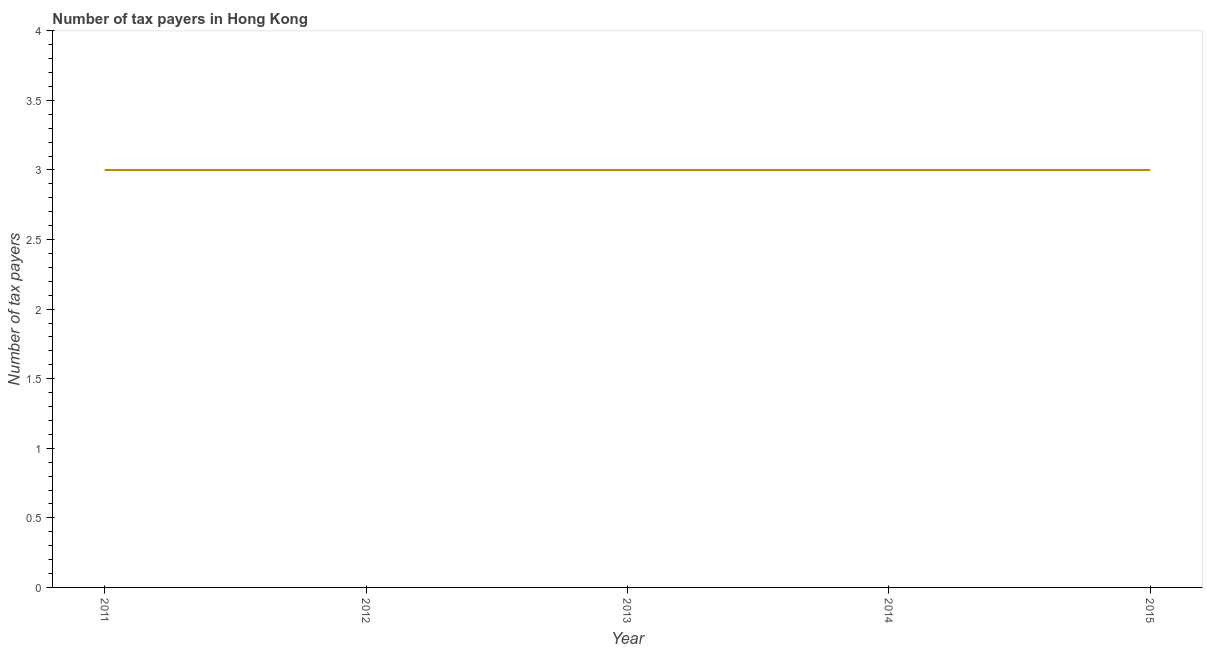What is the number of tax payers in 2015?
Offer a terse response. 3. Across all years, what is the maximum number of tax payers?
Offer a very short reply. 3. Across all years, what is the minimum number of tax payers?
Your response must be concise. 3. What is the sum of the number of tax payers?
Your answer should be compact. 15. What is the difference between the number of tax payers in 2011 and 2014?
Offer a very short reply. 0. What is the average number of tax payers per year?
Your response must be concise. 3. What is the median number of tax payers?
Ensure brevity in your answer.  3. In how many years, is the number of tax payers greater than 0.1 ?
Provide a short and direct response. 5. What is the ratio of the number of tax payers in 2011 to that in 2015?
Provide a succinct answer. 1. Is the number of tax payers in 2011 less than that in 2012?
Keep it short and to the point. No. Is the difference between the number of tax payers in 2012 and 2015 greater than the difference between any two years?
Make the answer very short. Yes. What is the difference between the highest and the second highest number of tax payers?
Give a very brief answer. 0. What is the difference between the highest and the lowest number of tax payers?
Your answer should be compact. 0. Does the number of tax payers monotonically increase over the years?
Provide a short and direct response. No. What is the difference between two consecutive major ticks on the Y-axis?
Your answer should be compact. 0.5. Are the values on the major ticks of Y-axis written in scientific E-notation?
Offer a terse response. No. What is the title of the graph?
Your response must be concise. Number of tax payers in Hong Kong. What is the label or title of the Y-axis?
Offer a terse response. Number of tax payers. What is the Number of tax payers in 2014?
Offer a very short reply. 3. What is the Number of tax payers of 2015?
Offer a very short reply. 3. What is the difference between the Number of tax payers in 2011 and 2012?
Offer a terse response. 0. What is the difference between the Number of tax payers in 2011 and 2015?
Offer a very short reply. 0. What is the difference between the Number of tax payers in 2012 and 2014?
Make the answer very short. 0. What is the difference between the Number of tax payers in 2012 and 2015?
Ensure brevity in your answer.  0. What is the ratio of the Number of tax payers in 2011 to that in 2012?
Give a very brief answer. 1. What is the ratio of the Number of tax payers in 2011 to that in 2013?
Offer a terse response. 1. What is the ratio of the Number of tax payers in 2011 to that in 2014?
Provide a succinct answer. 1. What is the ratio of the Number of tax payers in 2012 to that in 2013?
Your answer should be compact. 1. What is the ratio of the Number of tax payers in 2012 to that in 2014?
Provide a succinct answer. 1. What is the ratio of the Number of tax payers in 2013 to that in 2014?
Offer a very short reply. 1. What is the ratio of the Number of tax payers in 2013 to that in 2015?
Keep it short and to the point. 1. 